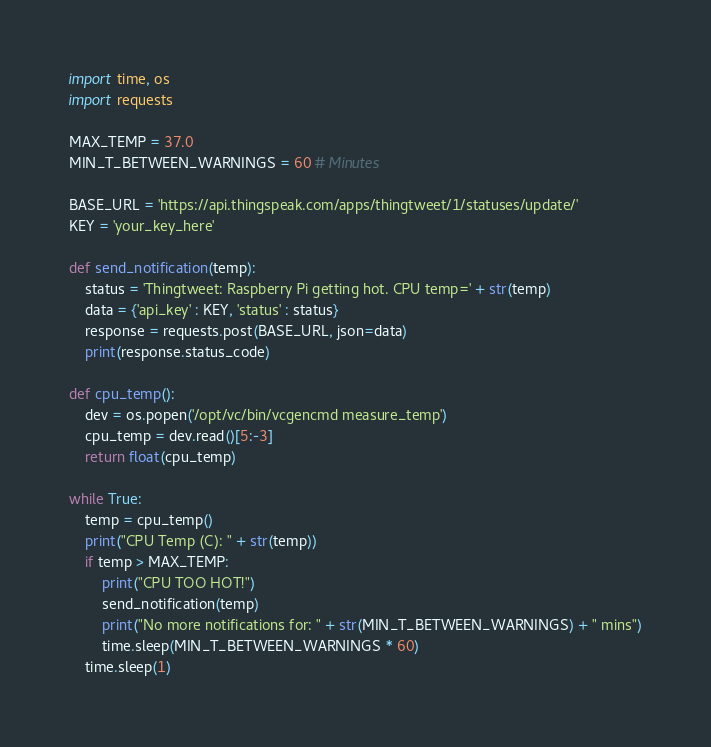<code> <loc_0><loc_0><loc_500><loc_500><_Python_>import time, os 
import requests

MAX_TEMP = 37.0
MIN_T_BETWEEN_WARNINGS = 60 # Minutes

BASE_URL = 'https://api.thingspeak.com/apps/thingtweet/1/statuses/update/'
KEY = 'your_key_here'

def send_notification(temp):
    status = 'Thingtweet: Raspberry Pi getting hot. CPU temp=' + str(temp)
    data = {'api_key' : KEY, 'status' : status}
    response = requests.post(BASE_URL, json=data)
    print(response.status_code)

def cpu_temp():
    dev = os.popen('/opt/vc/bin/vcgencmd measure_temp')
    cpu_temp = dev.read()[5:-3]
    return float(cpu_temp)
    
while True:
    temp = cpu_temp()
    print("CPU Temp (C): " + str(temp))
    if temp > MAX_TEMP:
        print("CPU TOO HOT!")
        send_notification(temp)
        print("No more notifications for: " + str(MIN_T_BETWEEN_WARNINGS) + " mins")
        time.sleep(MIN_T_BETWEEN_WARNINGS * 60)
    time.sleep(1)

</code> 